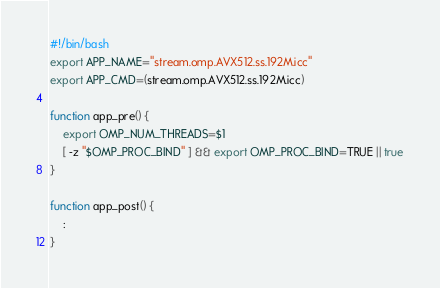<code> <loc_0><loc_0><loc_500><loc_500><_Bash_>#!/bin/bash
export APP_NAME="stream.omp.AVX512.ss.192M.icc"
export APP_CMD=(stream.omp.AVX512.ss.192M.icc)

function app_pre() {
    export OMP_NUM_THREADS=$1
    [ -z "$OMP_PROC_BIND" ] && export OMP_PROC_BIND=TRUE || true
}

function app_post() {
    :
}
</code> 